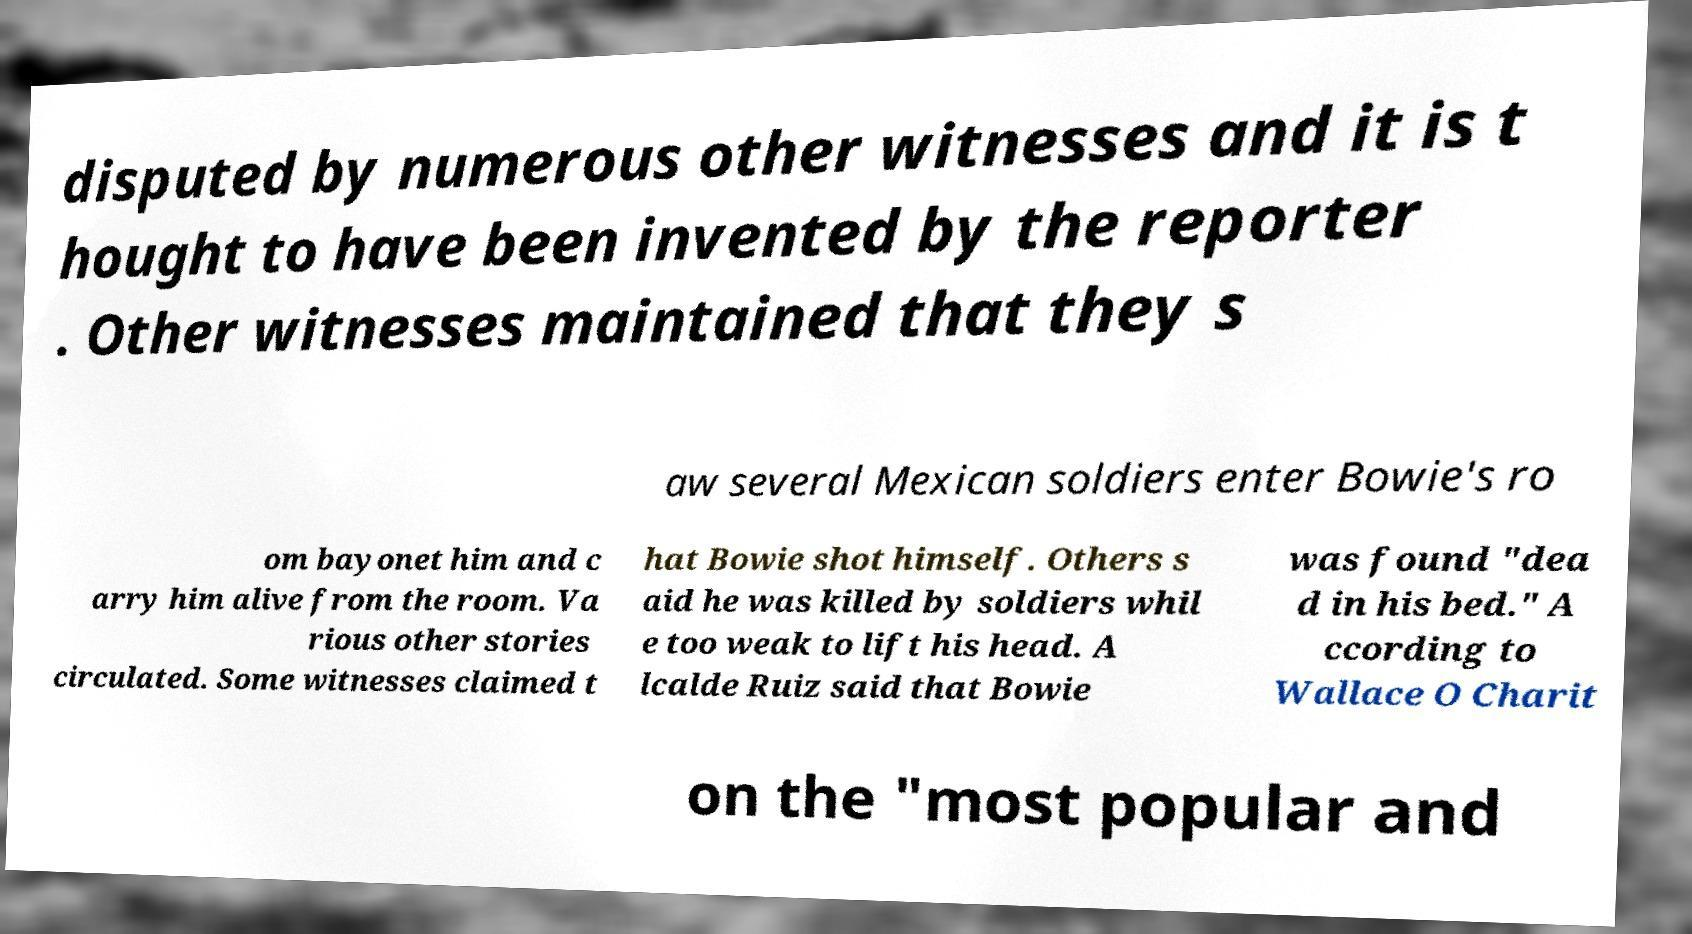For documentation purposes, I need the text within this image transcribed. Could you provide that? disputed by numerous other witnesses and it is t hought to have been invented by the reporter . Other witnesses maintained that they s aw several Mexican soldiers enter Bowie's ro om bayonet him and c arry him alive from the room. Va rious other stories circulated. Some witnesses claimed t hat Bowie shot himself. Others s aid he was killed by soldiers whil e too weak to lift his head. A lcalde Ruiz said that Bowie was found "dea d in his bed." A ccording to Wallace O Charit on the "most popular and 